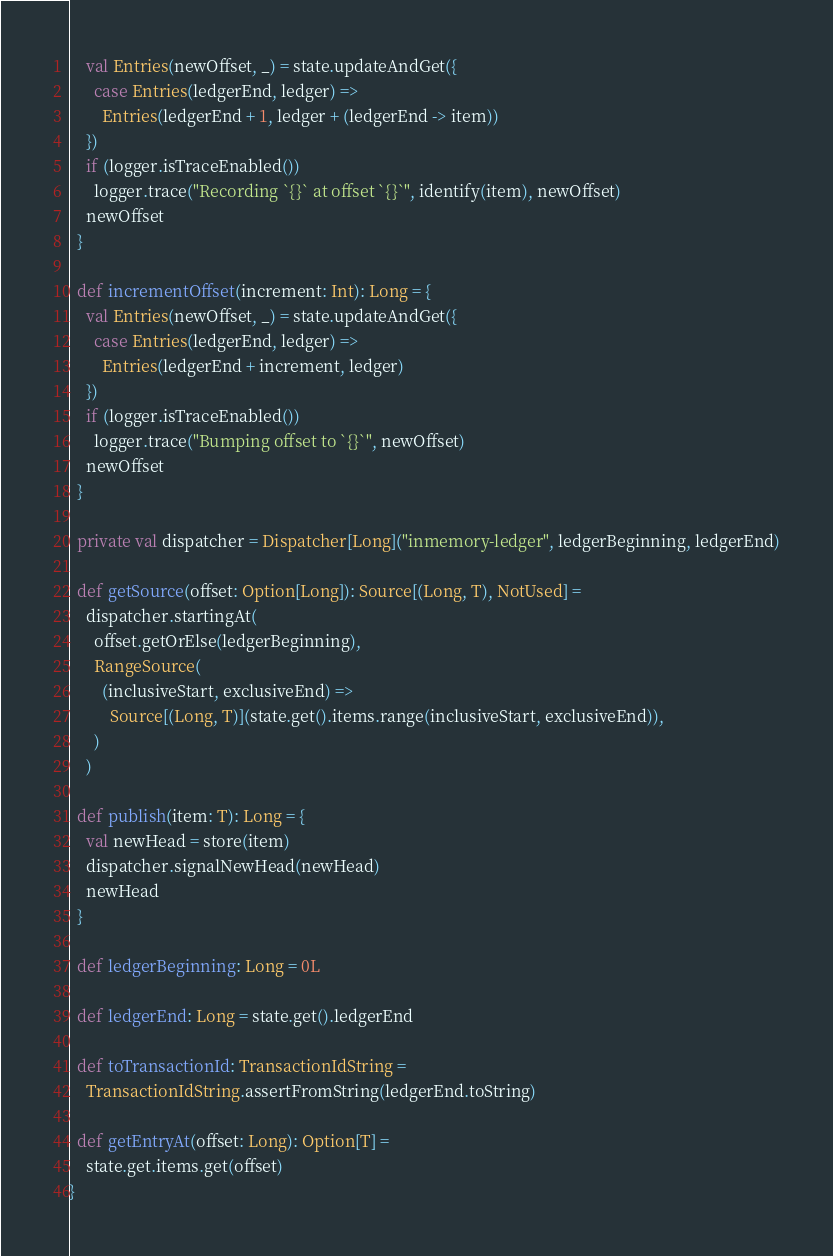<code> <loc_0><loc_0><loc_500><loc_500><_Scala_>    val Entries(newOffset, _) = state.updateAndGet({
      case Entries(ledgerEnd, ledger) =>
        Entries(ledgerEnd + 1, ledger + (ledgerEnd -> item))
    })
    if (logger.isTraceEnabled())
      logger.trace("Recording `{}` at offset `{}`", identify(item), newOffset)
    newOffset
  }

  def incrementOffset(increment: Int): Long = {
    val Entries(newOffset, _) = state.updateAndGet({
      case Entries(ledgerEnd, ledger) =>
        Entries(ledgerEnd + increment, ledger)
    })
    if (logger.isTraceEnabled())
      logger.trace("Bumping offset to `{}`", newOffset)
    newOffset
  }

  private val dispatcher = Dispatcher[Long]("inmemory-ledger", ledgerBeginning, ledgerEnd)

  def getSource(offset: Option[Long]): Source[(Long, T), NotUsed] =
    dispatcher.startingAt(
      offset.getOrElse(ledgerBeginning),
      RangeSource(
        (inclusiveStart, exclusiveEnd) =>
          Source[(Long, T)](state.get().items.range(inclusiveStart, exclusiveEnd)),
      )
    )

  def publish(item: T): Long = {
    val newHead = store(item)
    dispatcher.signalNewHead(newHead)
    newHead
  }

  def ledgerBeginning: Long = 0L

  def ledgerEnd: Long = state.get().ledgerEnd

  def toTransactionId: TransactionIdString =
    TransactionIdString.assertFromString(ledgerEnd.toString)

  def getEntryAt(offset: Long): Option[T] =
    state.get.items.get(offset)
}
</code> 